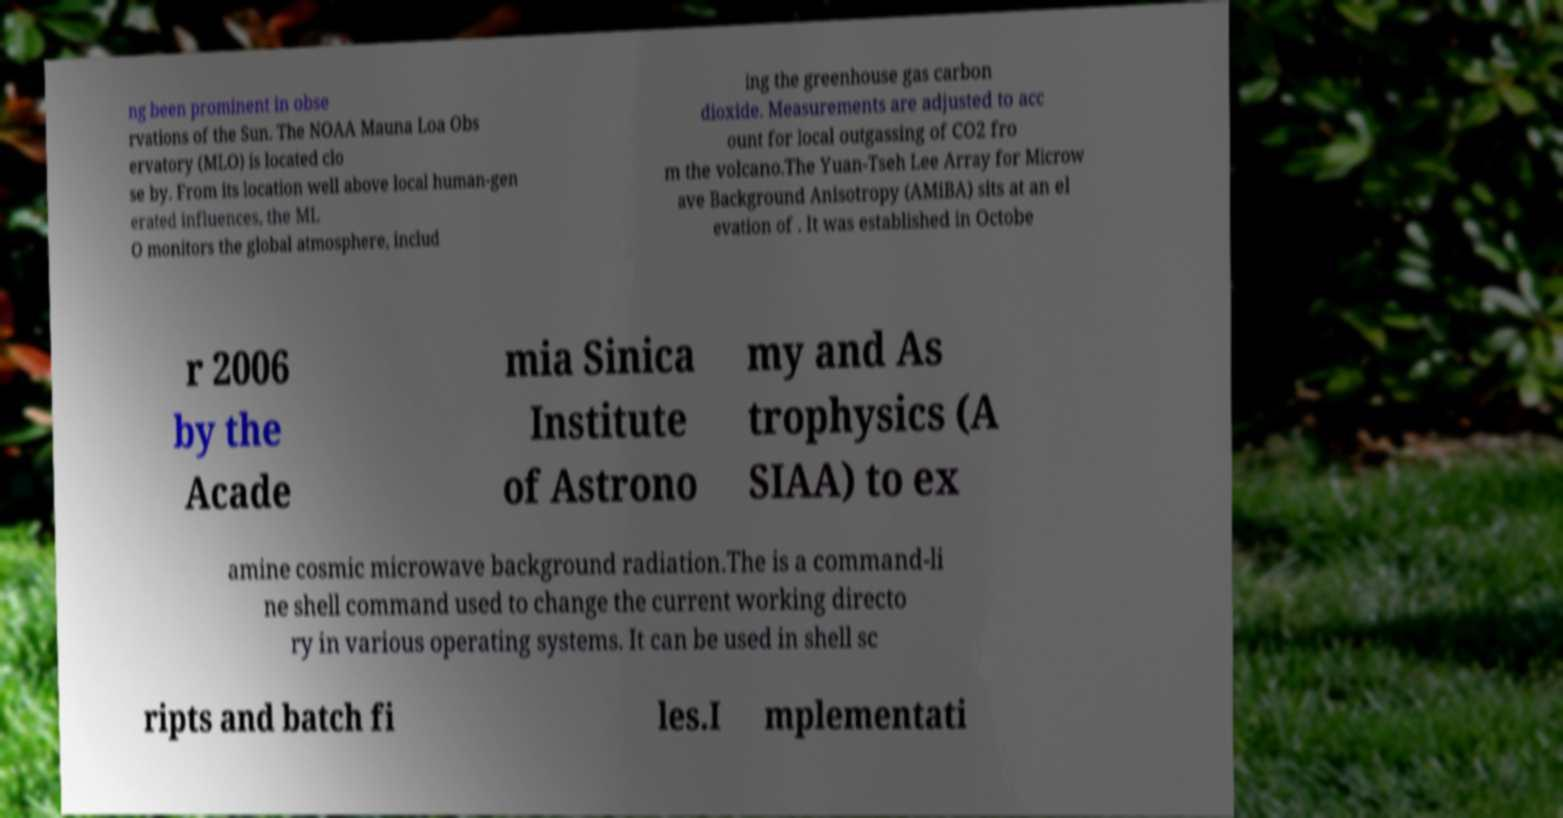For documentation purposes, I need the text within this image transcribed. Could you provide that? ng been prominent in obse rvations of the Sun. The NOAA Mauna Loa Obs ervatory (MLO) is located clo se by. From its location well above local human-gen erated influences, the ML O monitors the global atmosphere, includ ing the greenhouse gas carbon dioxide. Measurements are adjusted to acc ount for local outgassing of CO2 fro m the volcano.The Yuan-Tseh Lee Array for Microw ave Background Anisotropy (AMiBA) sits at an el evation of . It was established in Octobe r 2006 by the Acade mia Sinica Institute of Astrono my and As trophysics (A SIAA) to ex amine cosmic microwave background radiation.The is a command-li ne shell command used to change the current working directo ry in various operating systems. It can be used in shell sc ripts and batch fi les.I mplementati 